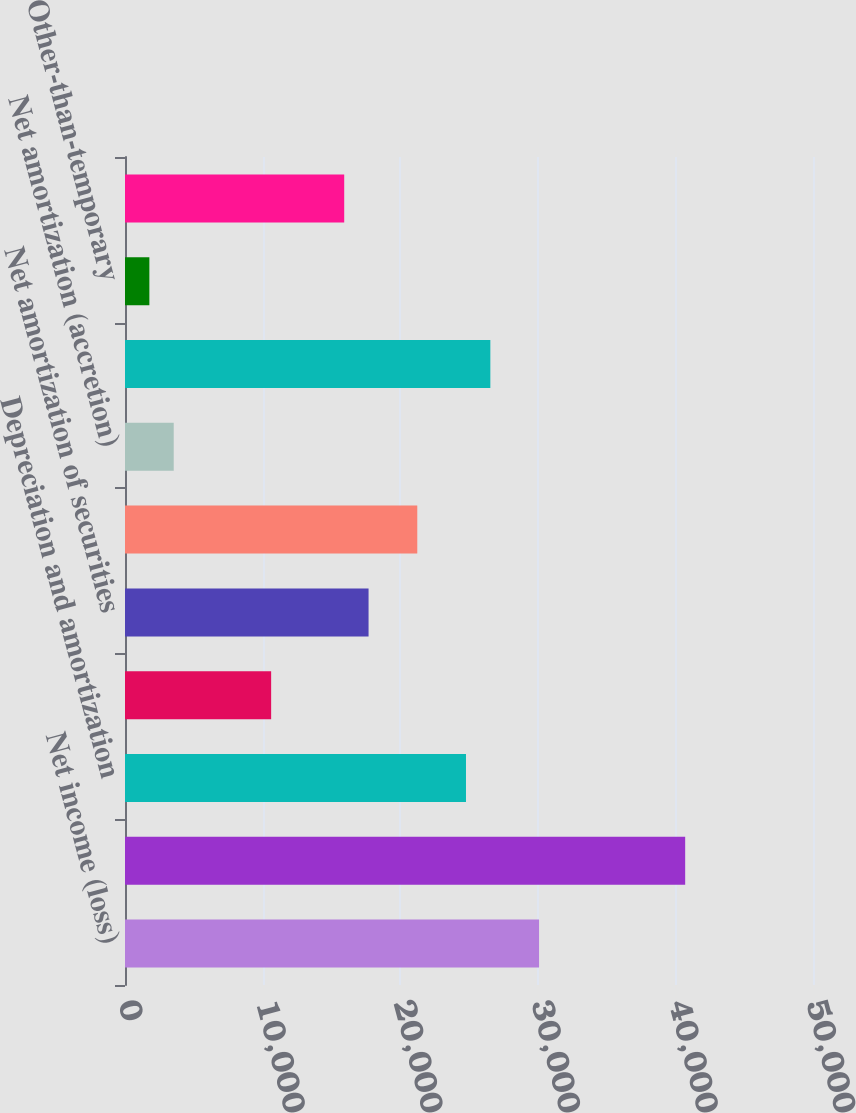Convert chart. <chart><loc_0><loc_0><loc_500><loc_500><bar_chart><fcel>Net income (loss)<fcel>Provision for loan losses<fcel>Depreciation and amortization<fcel>Provision for losses on other<fcel>Net amortization of securities<fcel>Net amortization of loans and<fcel>Net amortization (accretion)<fcel>Net securities gains<fcel>Other-than-temporary<fcel>Deferred income tax (benefit)<nl><fcel>30091<fcel>40711<fcel>24781<fcel>10621<fcel>17701<fcel>21241<fcel>3541<fcel>26551<fcel>1771<fcel>15931<nl></chart> 